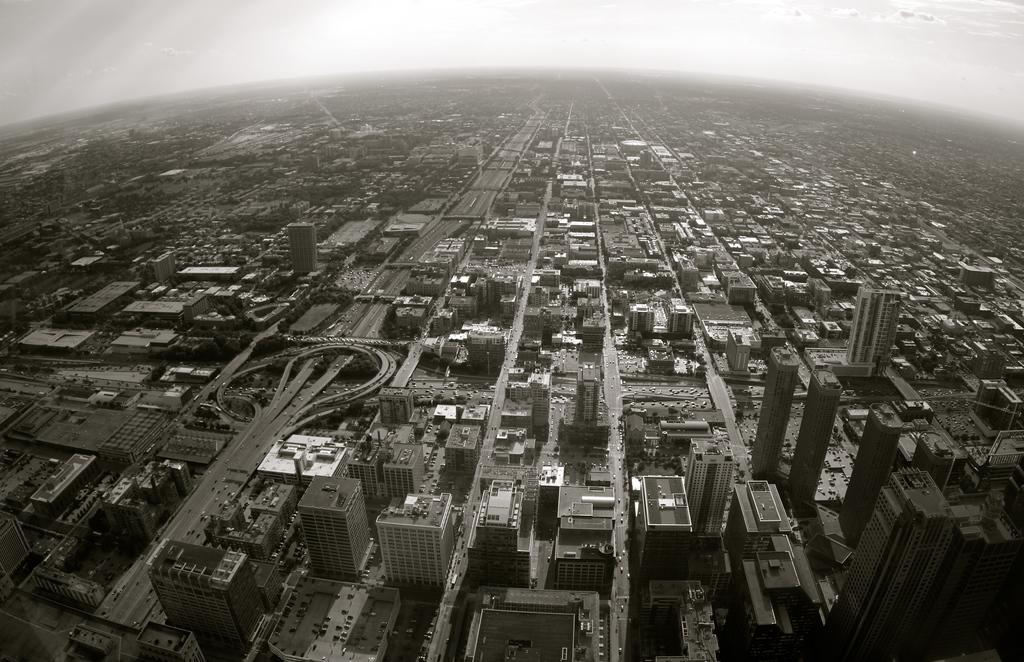What type of view is shown in the image? The image shows a top view of a city. What structures can be seen in the image? There are buildings in the image. What else can be seen in the image besides buildings? There are roads in the image. What is visible at the top of the image? The sky is visible at the top of the image. Can you see a quill being used to write on a horse in the image? There is no quill or horse present in the image; it shows a top view of a city with buildings and roads. 